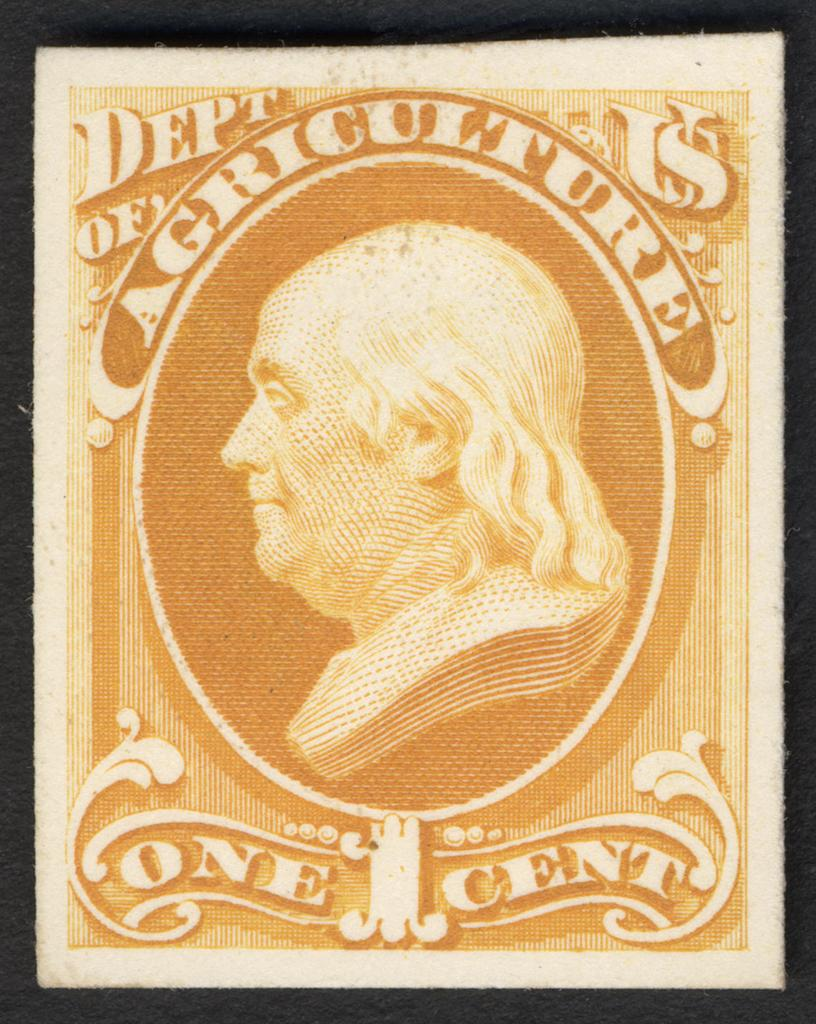What object is present in the image that typically holds a photo? There is a photo frame in the image. What can be seen inside the photo frame? The photo frame contains a person's photo. Is there any additional information on the photo frame besides the photo? Yes, there is text written on the photo frame. What type of truck is parked next to the photo frame in the image? There is no truck present in the image; it only features a photo frame with a person's photo and text. 